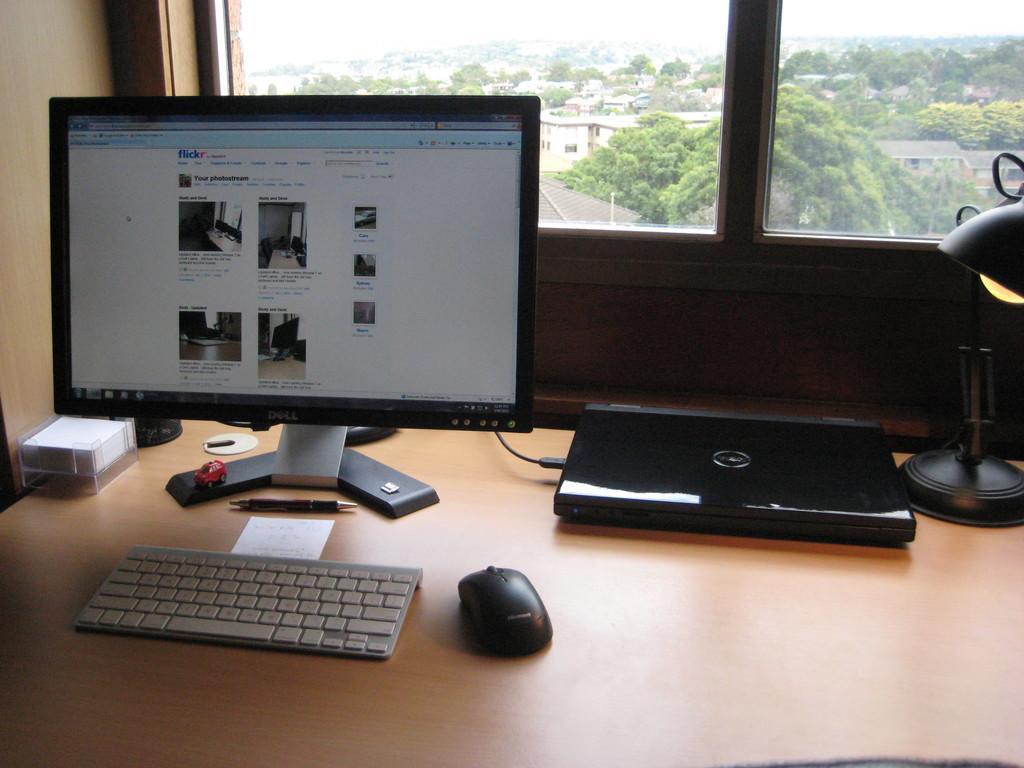Can you describe this image briefly? In this image on the left side there is one computer and keyboard and mouse and pen and one laptop is there on the table and on the right side there is a lamp and on the background there is a glass window and some trees and houses are there. 